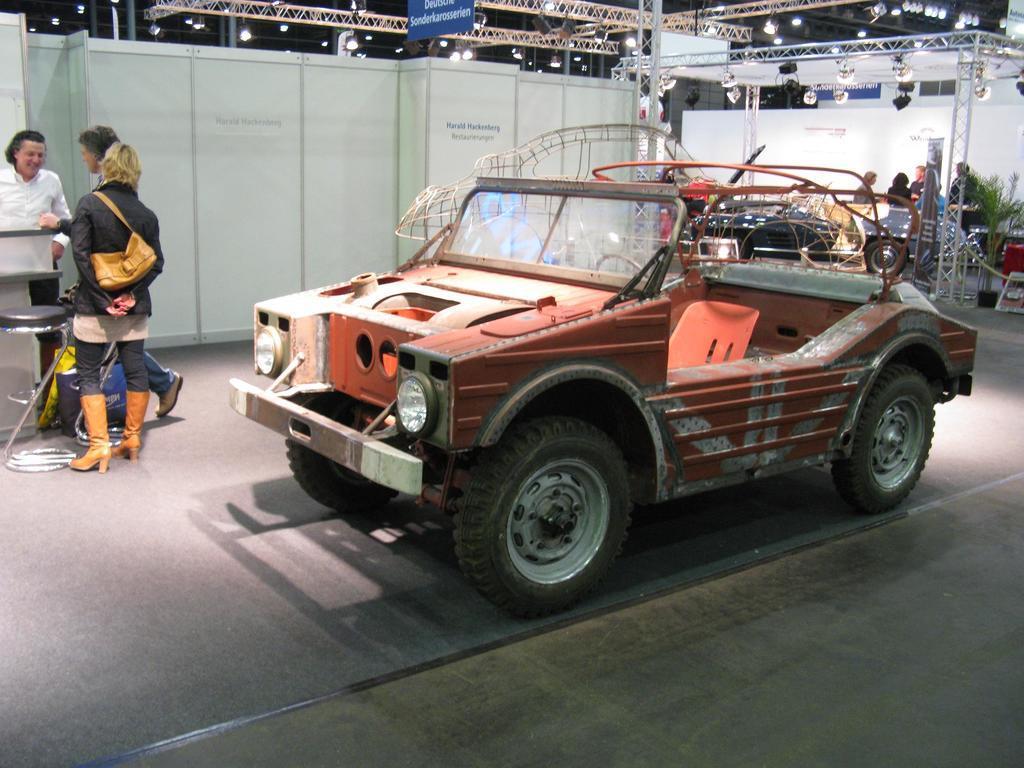In one or two sentences, can you explain what this image depicts? This picture seems to be clicked inside. In the foreground there is a red color vehicle parked on the ground. On the left we can see the group of persons and there are some objects. On the right we can see the group of persons standing on the ground and we can see the metal rods, focusing lights, wall and many other objects. 